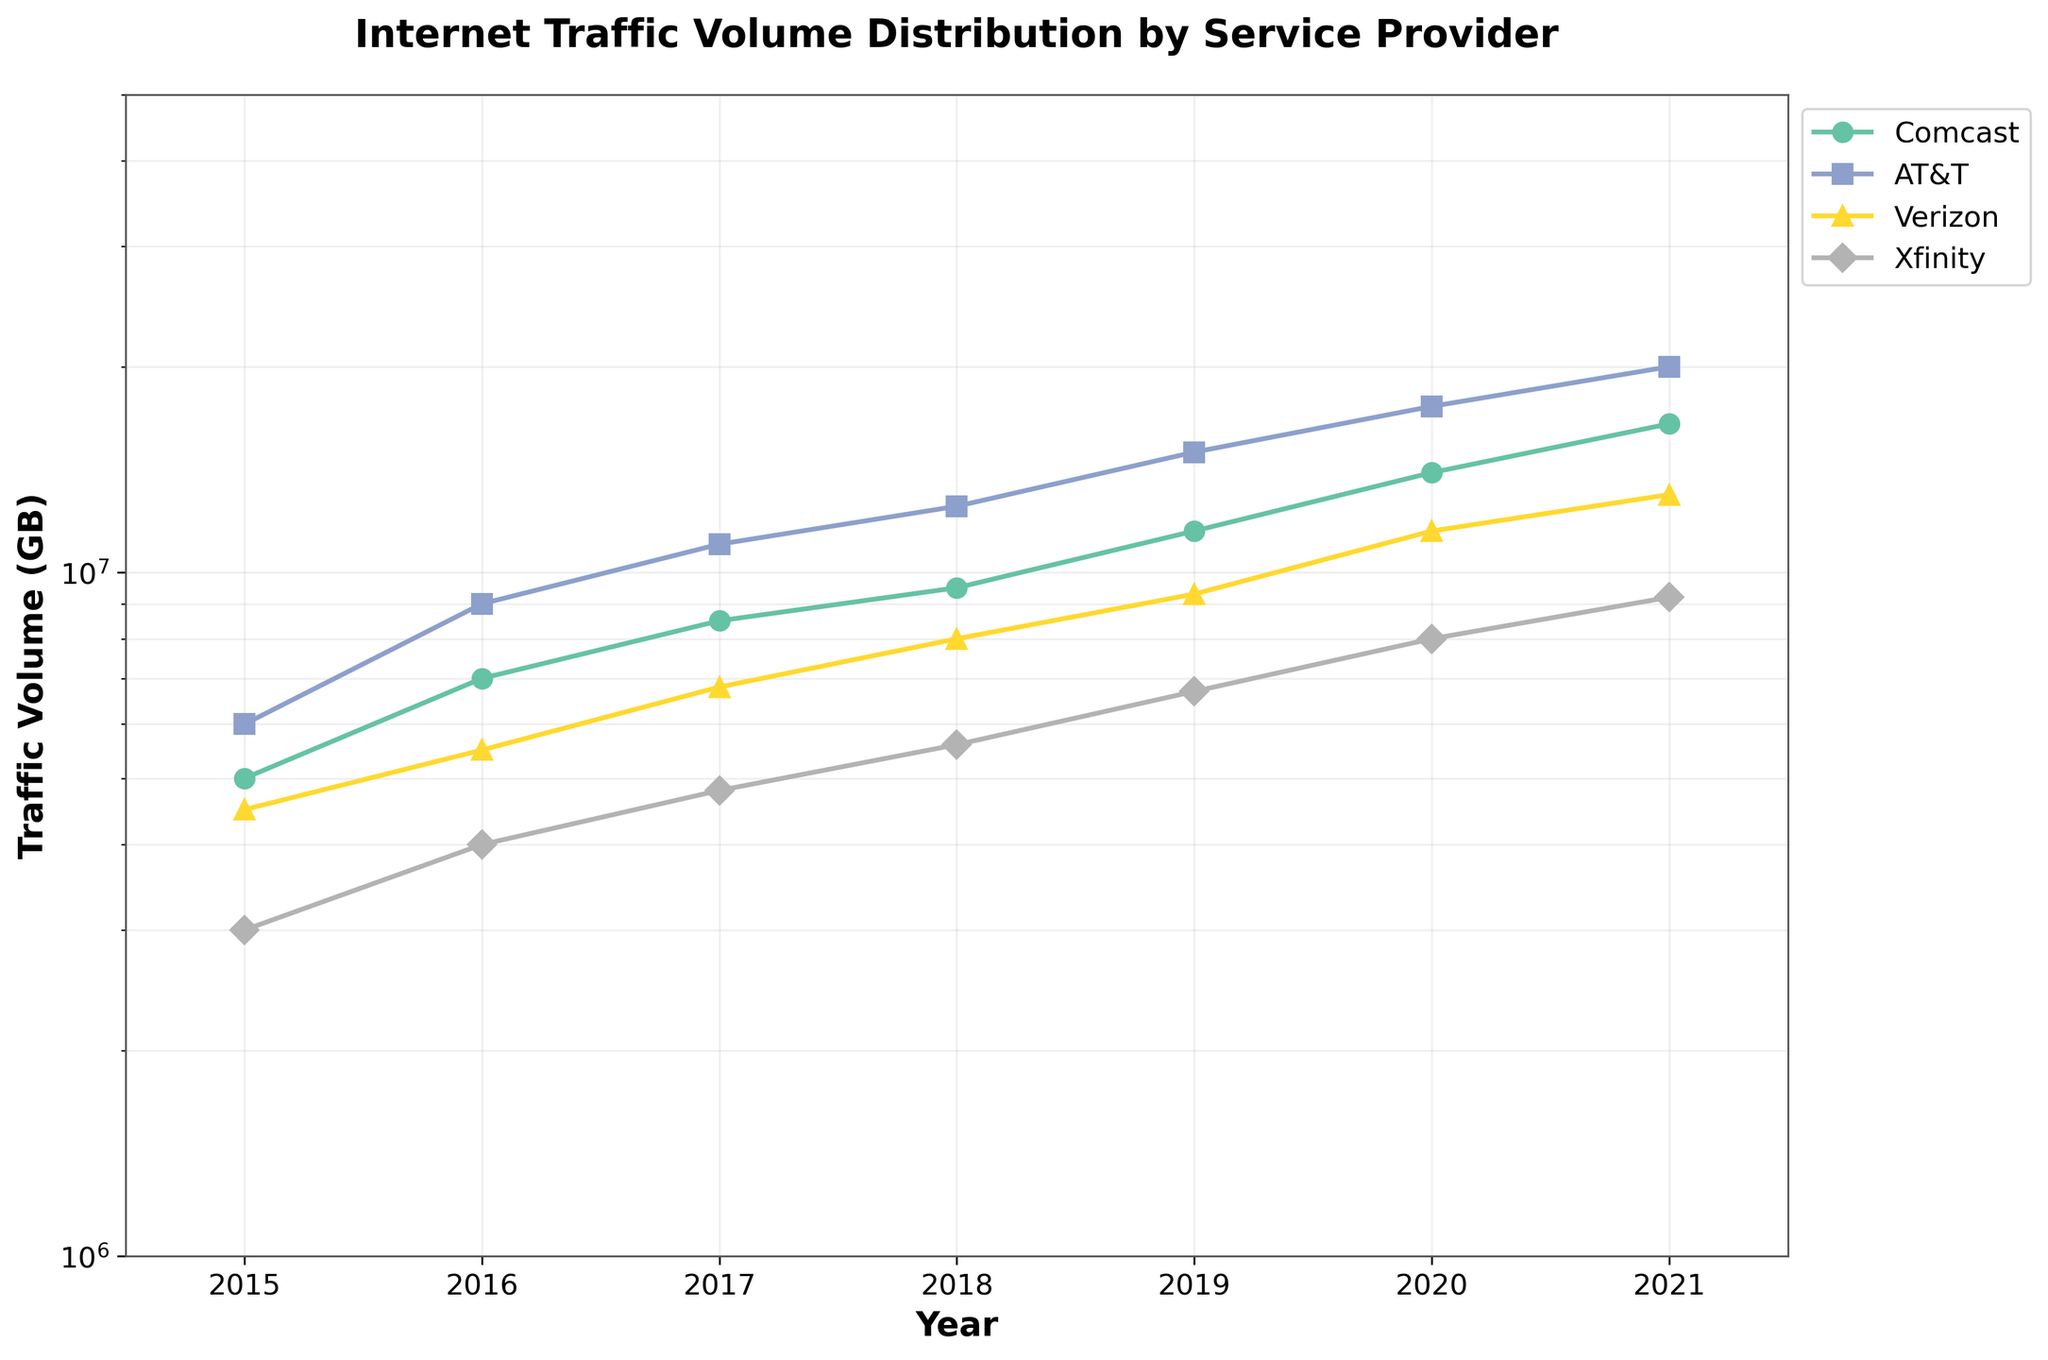What is the title of the plot? The title of the plot is located at the top of the figure, usually in bold and larger font compared to the other text in the plot.
Answer: Internet Traffic Volume Distribution by Service Provider Which service provider had the highest traffic volume in 2021? Look at the traffic volume represented on the y-axis for the year 2021 on the x-axis. Identify the highest value among all the lines representing different service providers.
Answer: AT&T What is the y-axis label? The y-axis label describes what is being measured on the vertical axis of the plot. It is usually found next to the vertical axis, written vertically for clarity.
Answer: Traffic Volume (GB) Between which years did Comcast experience the highest increase in traffic volume? Find the difference in traffic volume between consecutive years for Comcast. Identify the pair of years with the highest increase by comparing these differences.
Answer: 2019 to 2020 Which service provider had the lowest traffic volume in 2019? Locate the year 2019 on the x-axis. Compare the traffic volumes for all service providers at that point in time and identify the lowest value.
Answer: Xfinity By how much did AT&T's traffic volume grow from 2015 to 2021? Find the traffic volume for AT&T in 2015 and in 2021. Calculate the difference between these two values to determine the growth.
Answer: 14,000,000 GB Did any service provider's traffic volume decrease at any point in time? Examine the lines for each service provider over the years to see if any of them show a downward trend at any point.
Answer: No How many unique service providers are displayed in the plot? Count the number of distinct lines in the plot, as each line represents a different service provider.
Answer: 4 Between Verizon and Xfinity, which one saw a higher traffic volume increase between 2016 and 2017? Determine the traffic volumes for both service providers in 2016 and 2017. Calculate the differences and compare them to find which increase is larger.
Answer: Verizon What was the traffic volume of Verizon in 2018? Find the point in the plot where Verizon’s line intersects the year 2018 on the x-axis and read the corresponding value on the y-axis.
Answer: 8,000,000 GB 